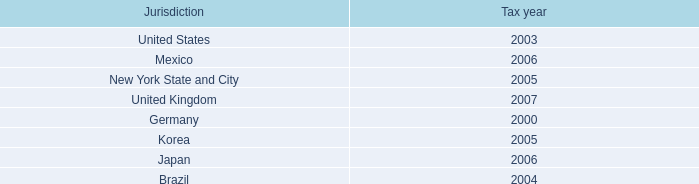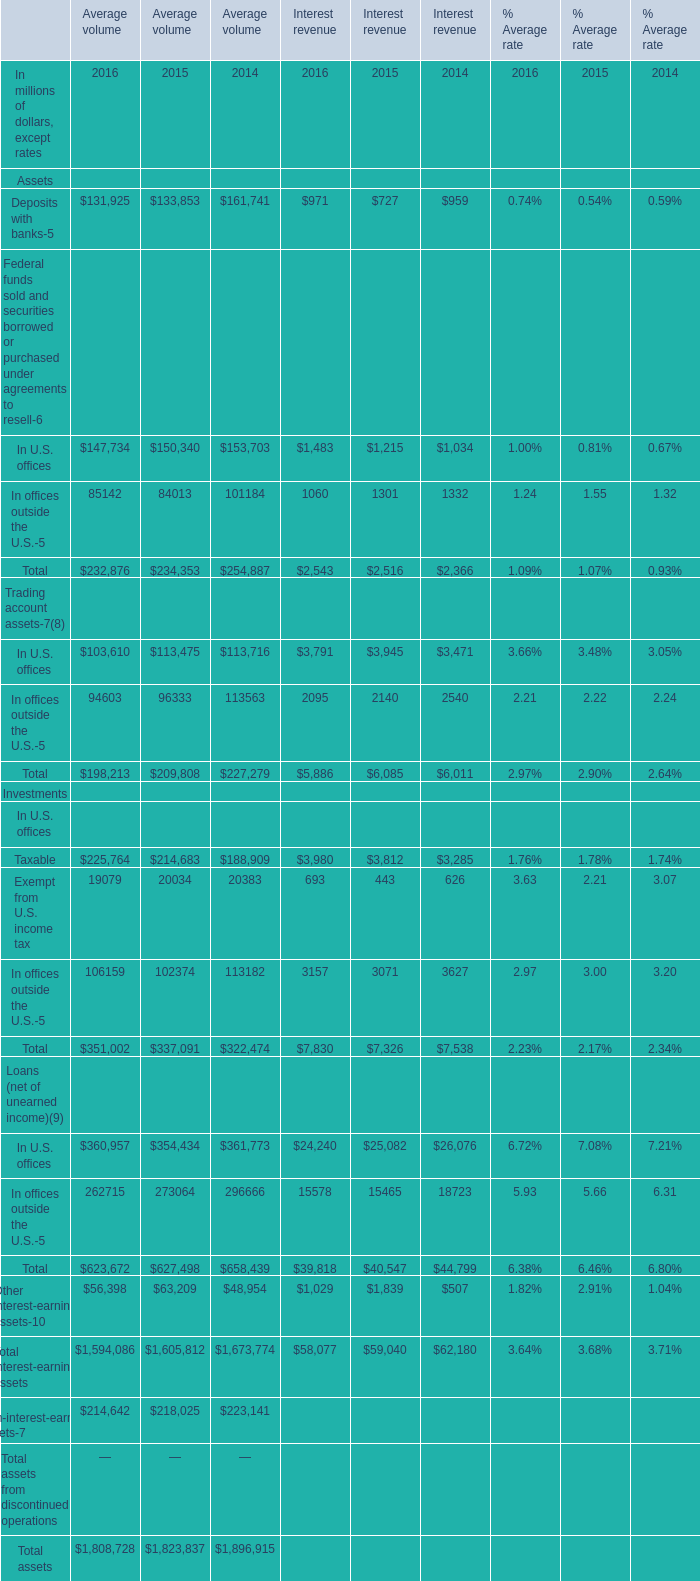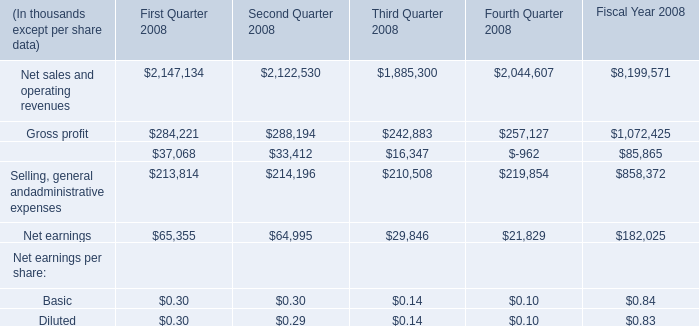what percent of foreign pretax earnings in 2007 were from discontinued operations? 
Computations: (0.7 / 9.1)
Answer: 0.07692. 